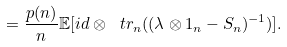Convert formula to latex. <formula><loc_0><loc_0><loc_500><loc_500>= \frac { p ( n ) } { n } \mathbb { E } [ i d \otimes \ t r _ { n } ( ( \lambda \otimes 1 _ { n } - S _ { n } ) ^ { - 1 } ) ] .</formula> 